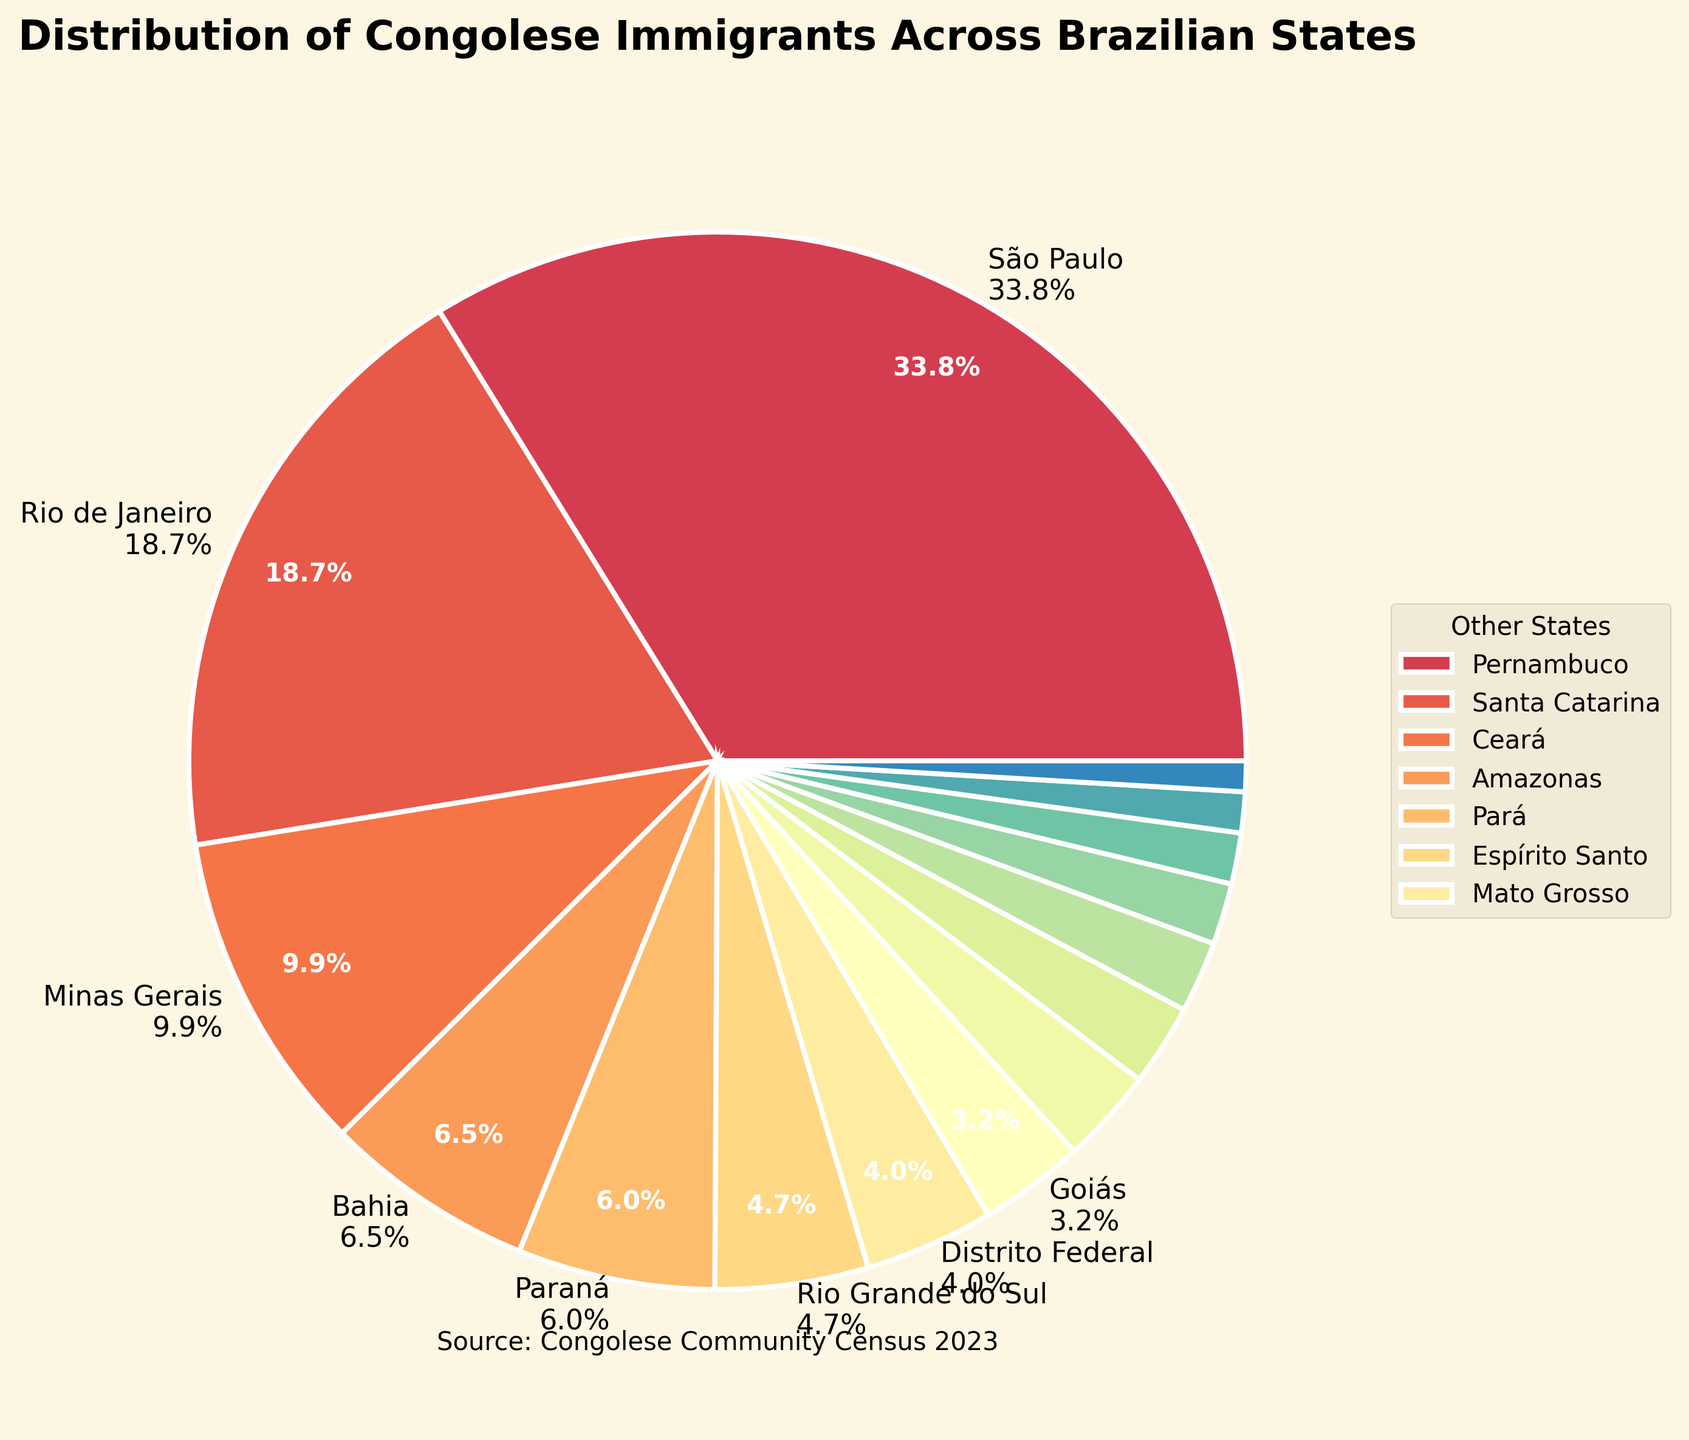What percentage of Congolese immigrants live in São Paulo? The pie chart shows São Paulo has the largest section with a label that includes the exact percentage.
Answer: 42.2% Which state has a larger percentage of Congolese immigrants, Rio de Janeiro or Minas Gerais? By comparing the pie chart slices, Rio de Janeiro has a larger slice than Minas Gerais. The labels also provide the percentages for verification.
Answer: Rio de Janeiro How many states have less than 3% of the Congolese immigrant population each? Count the number of unlabeled states and smaller slices grouped in the legend.
Answer: 12 What is the total percentage of Congolese immigrants in São Paulo, Rio de Janeiro, and Minas Gerais combined? Add the percentages of São Paulo (42.2%), Rio de Janeiro (23.4%), and Minas Gerais (12.4%).
Answer: 78.0% Is the percentage of Congolese immigrants in Bahia greater than that in Paraná? Compare the sizes of the slices for Bahia and Paraná. Bahia has a larger slice and the labeled percentage confirms it.
Answer: Yes Which states are grouped as "Other States" in the legend? Look at the states listed in the legend for smaller slices.
Answer: Distrito Federal, Goiás, Pernambuco, Santa Catarina, Ceará, Amazonas, Pará, Espírito Santo, Mato Grosso Does Paraná or Rio Grande do Sul have a higher percentage of Congolese immigrants? Compare the slices for Paraná and Rio Grande do Sul. Paraná's slice is slightly larger.
Answer: Paraná If you sum up the percentages of all states excluding São Paulo, is the resulting percentage less than São Paulo's? Subtract São Paulo's percentage (42.2%) from 100%.
Answer: No Are there any states with exactly 3% of Congolese immigrants? Check all labeled percentages for any state exactly at 3%.
Answer: No 